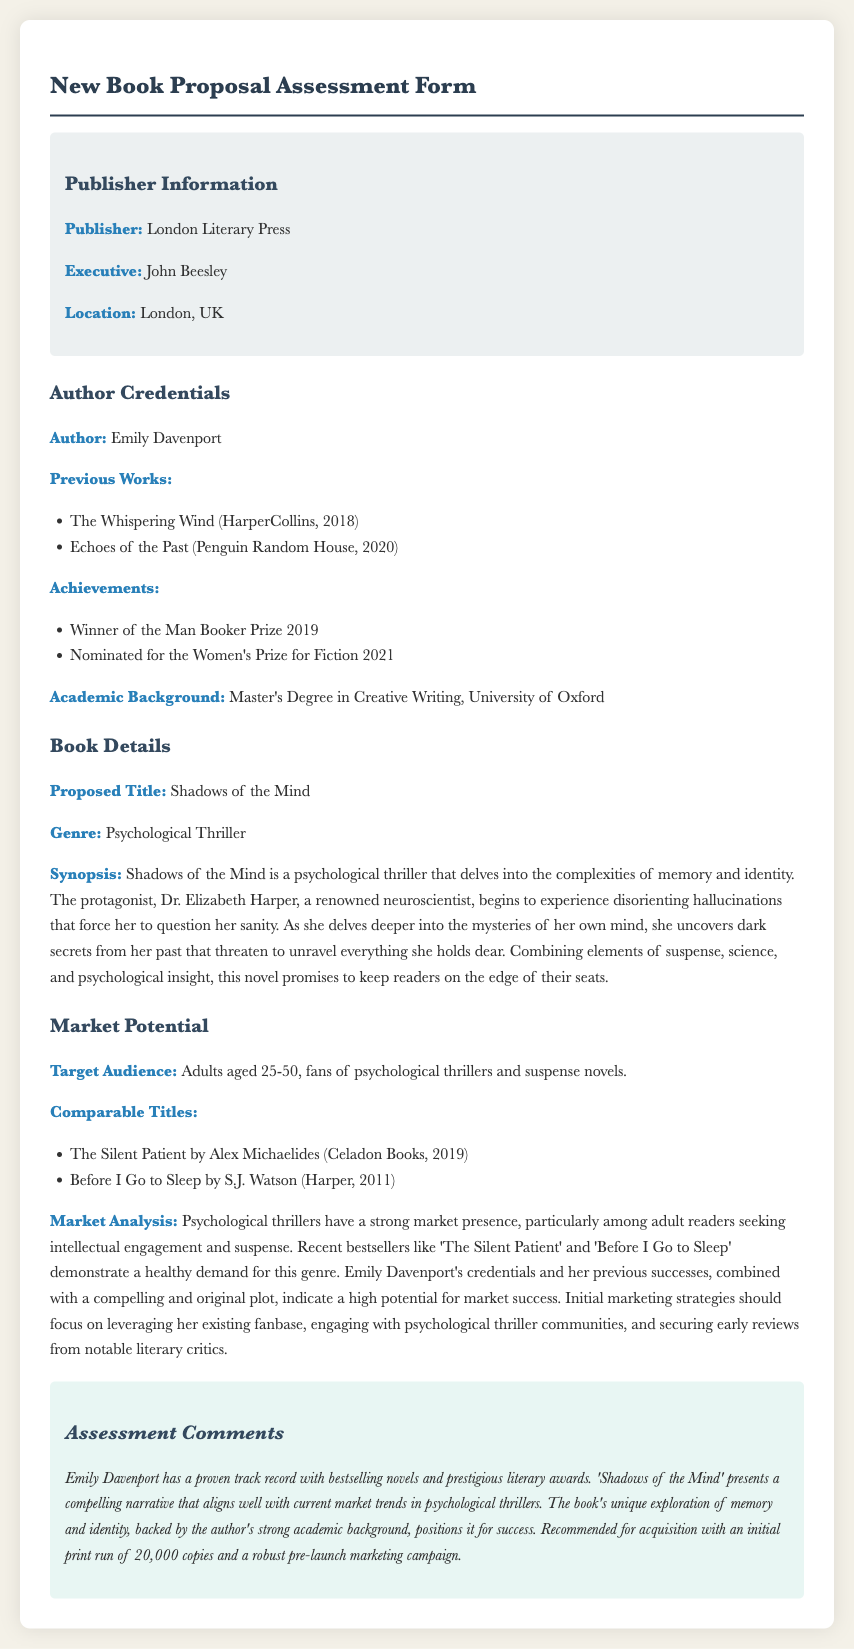What is the name of the author? The author's name is listed in the document under Author Credentials.
Answer: Emily Davenport What is the proposed title of the book? The proposed title is mentioned in the Book Details section of the document.
Answer: Shadows of the Mind Which genre does the book belong to? The genre is specified in the Book Details section of the document.
Answer: Psychological Thriller What year did Emily Davenport win the Man Booker Prize? The award year is provided in the Achievements list within the Author Credentials.
Answer: 2019 What is the target audience age range? The target audience is outlined in the Market Potential section of the document.
Answer: 25-50 Name one comparable title listed in the document. The comparable titles are mentioned in the Market Potential section, and any one can be identified as per the document.
Answer: The Silent Patient What is the initial print run recommended for the book? The recommended print run is provided in the Assessment Comments section toward the end of the document.
Answer: 20,000 copies What is the main theme explored in the book? The main theme is derived from the synopsis which describes the essence of the book.
Answer: Memory and identity What is the author's academic background? The academic background is noted in the Author Credentials section of the document.
Answer: Master's Degree in Creative Writing, University of Oxford 